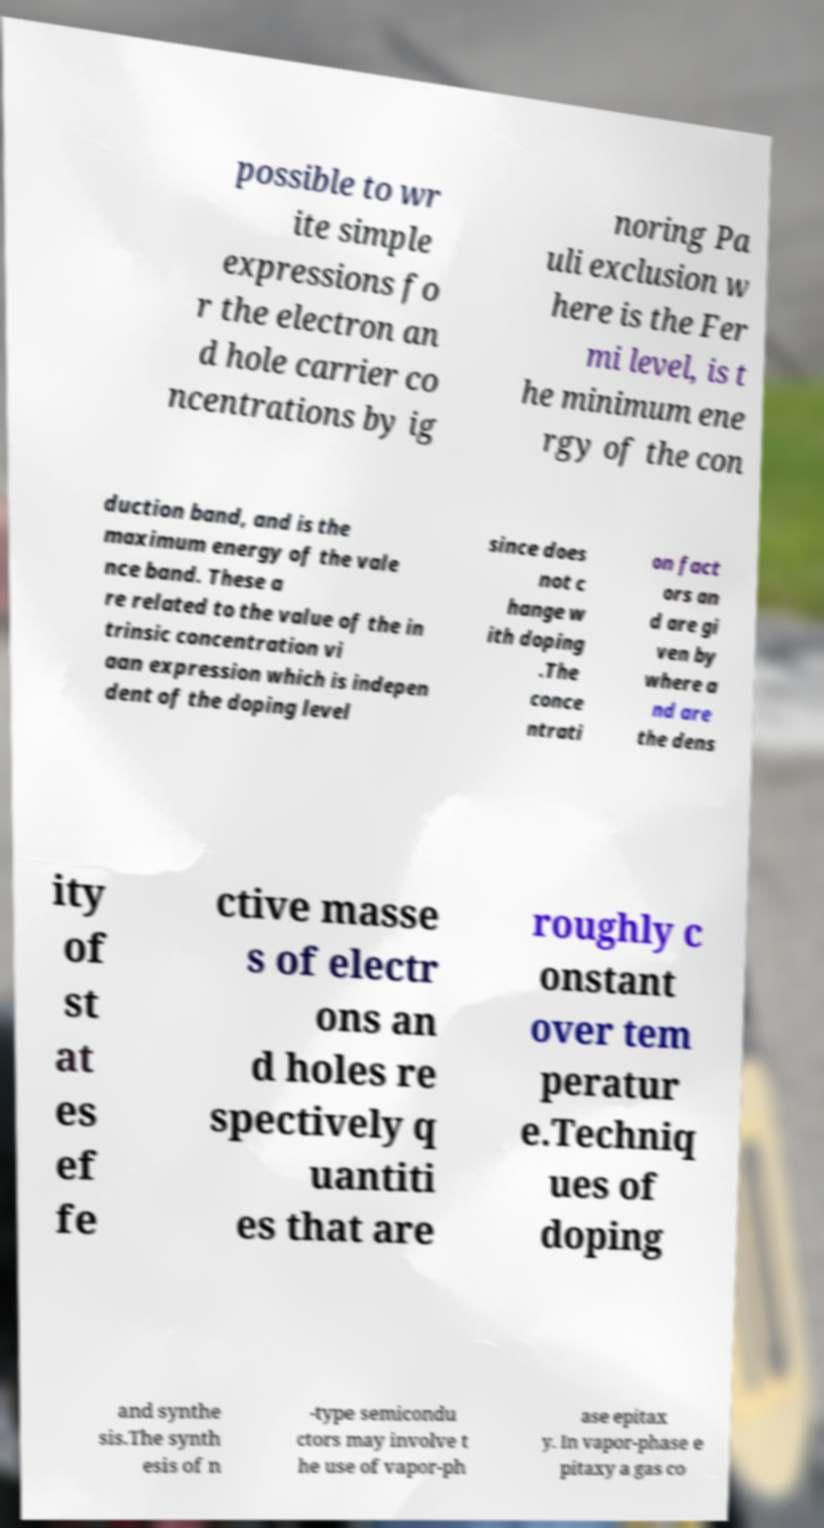I need the written content from this picture converted into text. Can you do that? possible to wr ite simple expressions fo r the electron an d hole carrier co ncentrations by ig noring Pa uli exclusion w here is the Fer mi level, is t he minimum ene rgy of the con duction band, and is the maximum energy of the vale nce band. These a re related to the value of the in trinsic concentration vi aan expression which is indepen dent of the doping level since does not c hange w ith doping .The conce ntrati on fact ors an d are gi ven by where a nd are the dens ity of st at es ef fe ctive masse s of electr ons an d holes re spectively q uantiti es that are roughly c onstant over tem peratur e.Techniq ues of doping and synthe sis.The synth esis of n -type semicondu ctors may involve t he use of vapor-ph ase epitax y. In vapor-phase e pitaxy a gas co 